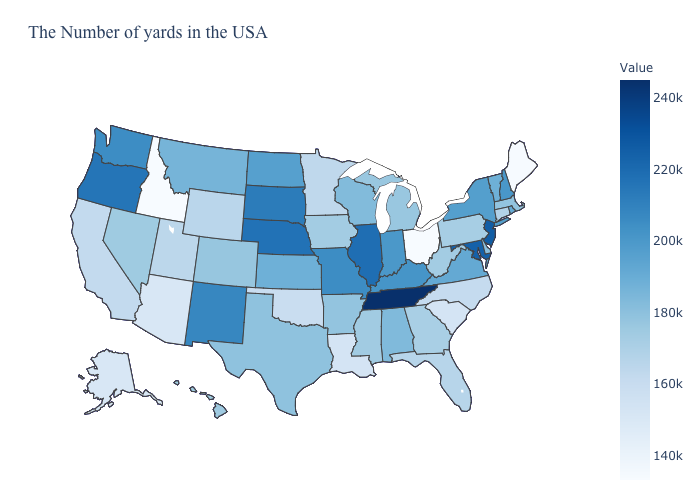Is the legend a continuous bar?
Write a very short answer. Yes. Among the states that border New Hampshire , does Vermont have the highest value?
Give a very brief answer. Yes. Is the legend a continuous bar?
Give a very brief answer. Yes. Does Ohio have the lowest value in the USA?
Write a very short answer. Yes. Which states have the lowest value in the USA?
Concise answer only. Ohio. Does Ohio have the highest value in the MidWest?
Answer briefly. No. Among the states that border Arizona , which have the lowest value?
Short answer required. California. 